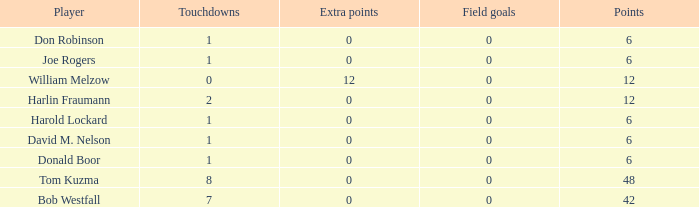Name the points for donald boor 6.0. 